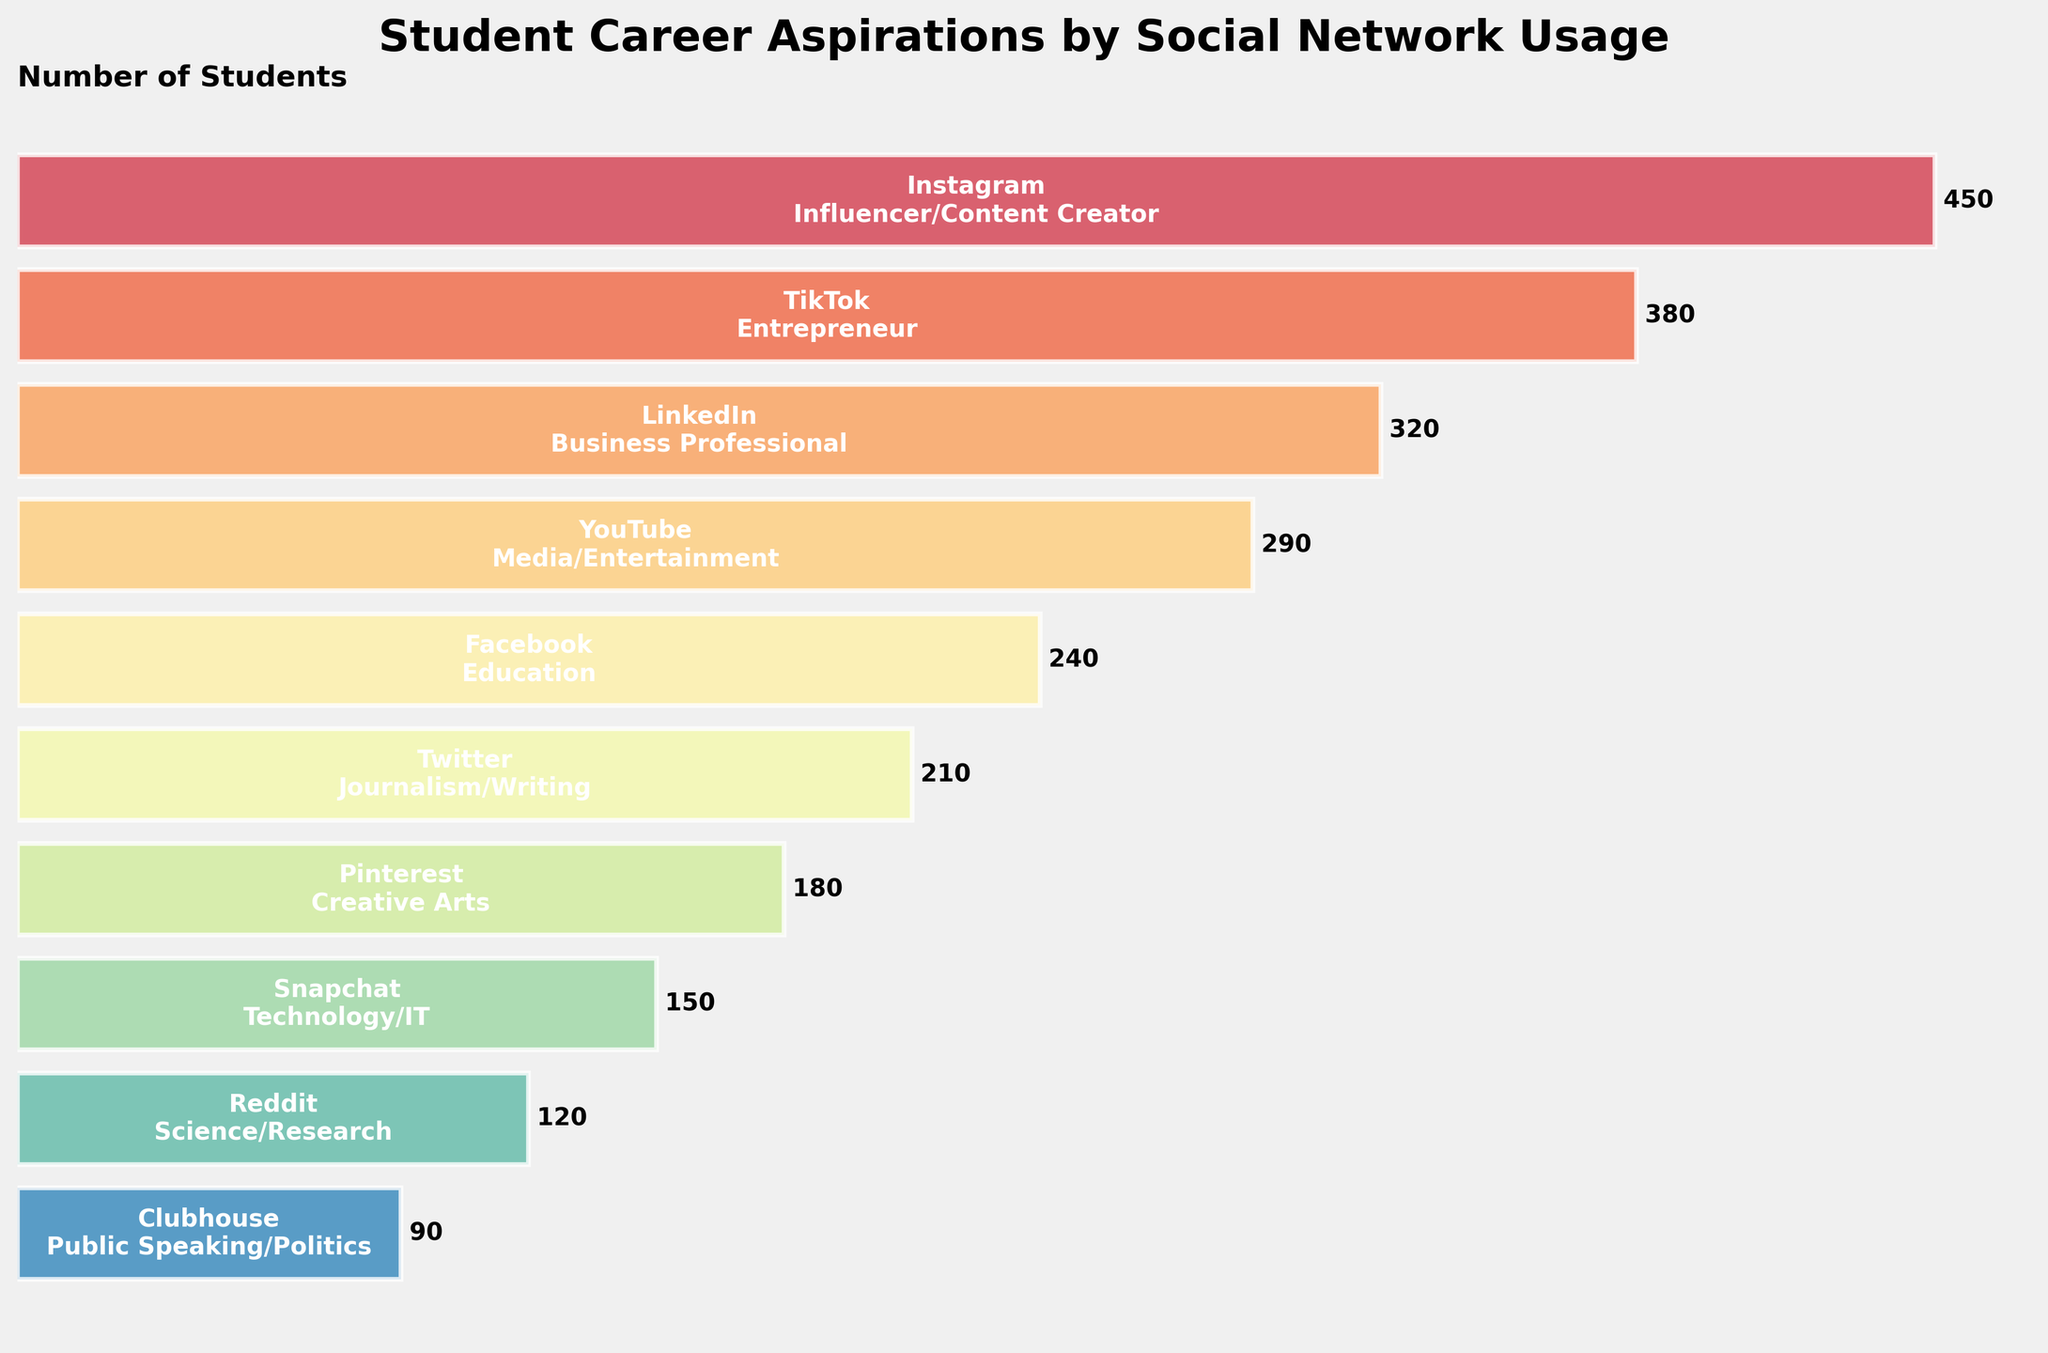What social network has the highest number of students aspiring to be influencers/content creators? By visually inspecting the top bar in the funnel chart, which is labeled "Instagram" for "Influencer/Content Creator" and extends the furthest to the right, we can identify the social network with the highest number of students for this aspiration.
Answer: Instagram How many students aspire to be business professionals based on their usage of LinkedIn? Locate the bar labeled "LinkedIn" and "Business Professional" in the funnel chart, and read the corresponding number of students displayed next to the bar on the right.
Answer: 320 What is the total number of students aspiring to careers in media/entertainment and education based on their social network usage? Identify bars labeled "YouTube" for "Media/Entertainment" and "Facebook" for "Education." Sum their respective numbers: 290 (YouTube) + 240 (Facebook) = 530.
Answer: 530 Which social network is associated with the fewest students aspiring to a career in public speaking/politics? Look for the shortest bar in the funnel chart, which is labeled "Clubhouse" for "Public Speaking/Politics." The number of students next to this bar is the lowest.
Answer: Clubhouse Which two social networks have the closest number of students aspiring to journalism/writing and creative arts, and what is their combined total? Find and compare bars labeled "Twitter" for "Journalism/Writing" (210 students) and "Pinterest" for "Creative Arts" (180 students). Sum these numbers: 210 + 180 = 390.
Answer: 390 What is the difference in the number of students aspiring to be technology/IT professionals using Snapchat and those aspiring to be science researchers using Reddit? Compare the bars labeled "Snapchat" for "Technology/IT" (150 students) and "Reddit" for "Science/Research" (120 students). Find the difference: 150 - 120 = 30.
Answer: 30 Which social network is linked to more career aspirations in creative arts: Pinterest or any other network? Locate the bar labeled "Pinterest" for "Creative Arts" and check its length against other bars; note that 180 students is exclusive to Pinterest for this career aspiration.
Answer: Pinterest Are there more students aspiring to be entrepreneurs on TikTok or business professionals on LinkedIn? Compare the lengths of the bars labeled "TikTok" for "Entrepreneur" (380 students) and "LinkedIn" for "Business Professional" (320 students).
Answer: TikTok Which career aspiration linked to a social network has fewer than 200 students? Identify the shortest bars and their labels. The bars labeled "Twitter" for "Journalism/Writing" (210) and below are candidates. Snapchat (150), Reddit (120), and Clubhouse (90) meet this criterion.
Answer: Technology/IT, Science/Research, Public Speaking/Politics What percentage of students aspiring to a career in education use Facebook? Identify the bar labeled "Facebook" for "Education" with 240 students. Sum all bars: 450+380+320+290+240+210+180+150+120+90 = 2430. Calculate percentage: (240/2430) * 100 ≈ 9.88%.
Answer: ~9.88% 